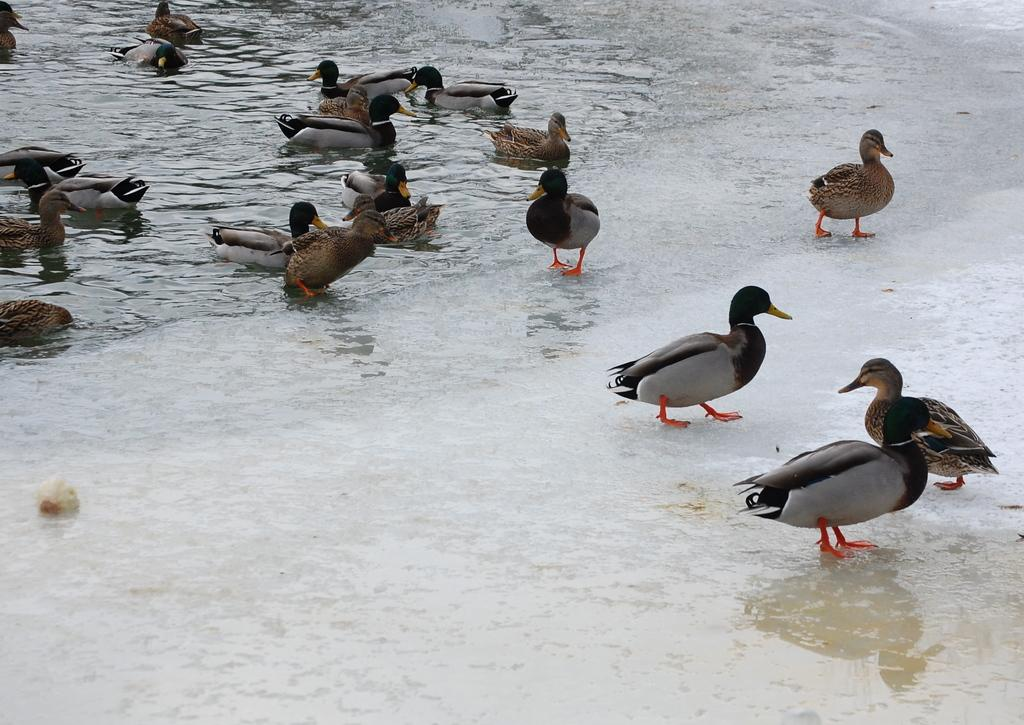What type of animals are in the image? There is a group of mallard birds in the image. Can you describe the appearance of the mallard birds? The mallard birds are in different colors. Where are some of the mallard birds located in the image? Some of the mallard birds are in the right corner of the image. Where are the remaining mallard birds located in the image? The remaining mallard birds are in the water in the left corner of the image. What type of button can be seen floating in the water with the mallard birds? There is no button present in the image; it features a group of mallard birds in different colors, with some in the right corner and the rest in the water in the left corner. Are there any boats visible in the image with the mallard birds? No, there are no boats present in the image; it only features a group of mallard birds in different colors, with some in the right corner and the rest in the water in the left corner. 